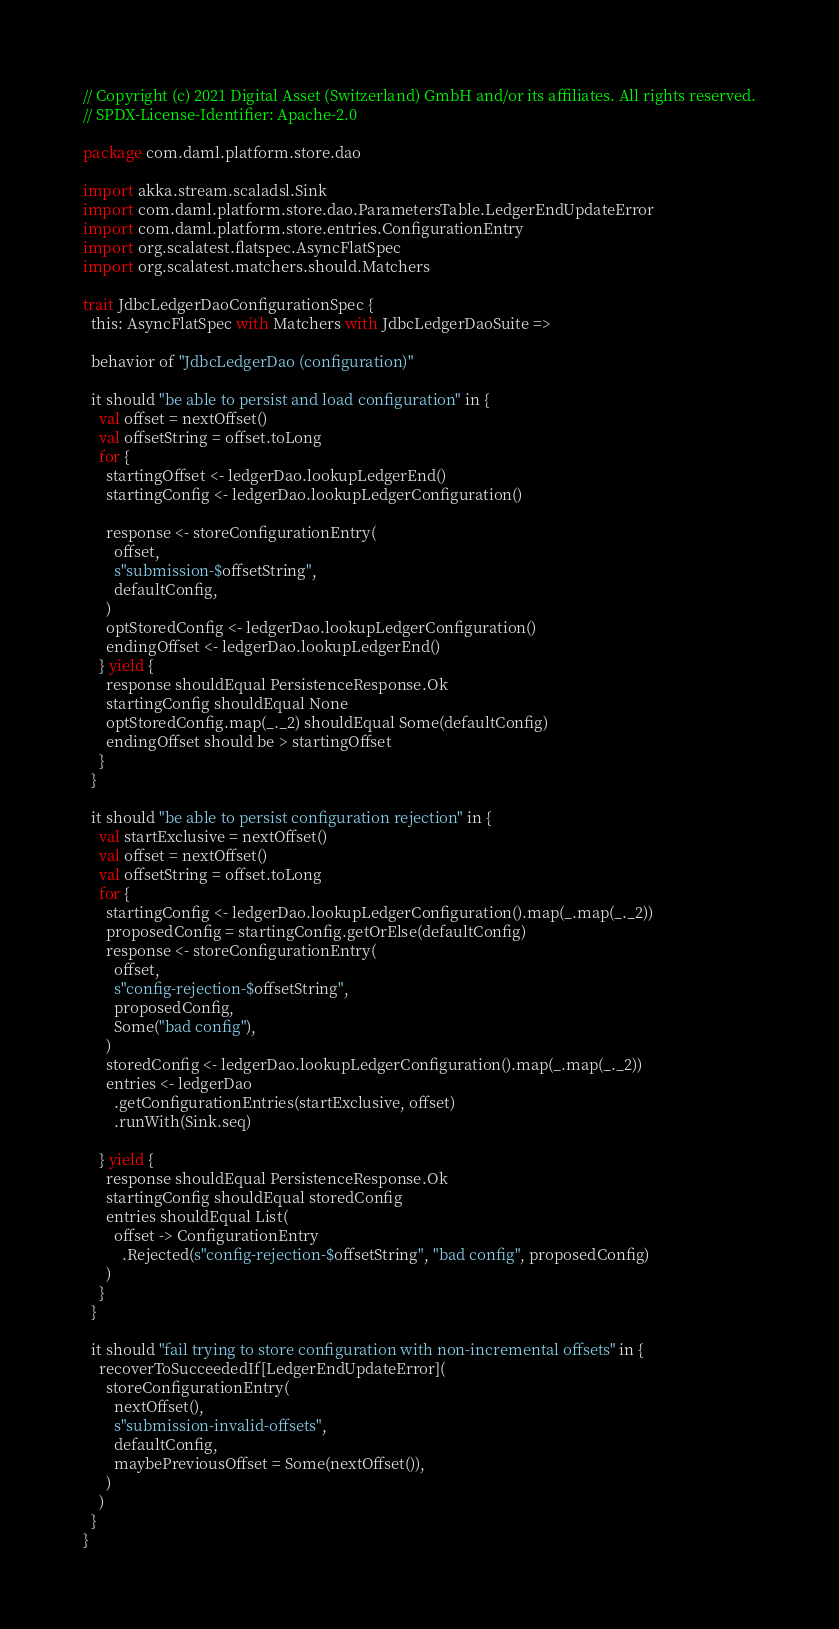<code> <loc_0><loc_0><loc_500><loc_500><_Scala_>// Copyright (c) 2021 Digital Asset (Switzerland) GmbH and/or its affiliates. All rights reserved.
// SPDX-License-Identifier: Apache-2.0

package com.daml.platform.store.dao

import akka.stream.scaladsl.Sink
import com.daml.platform.store.dao.ParametersTable.LedgerEndUpdateError
import com.daml.platform.store.entries.ConfigurationEntry
import org.scalatest.flatspec.AsyncFlatSpec
import org.scalatest.matchers.should.Matchers

trait JdbcLedgerDaoConfigurationSpec {
  this: AsyncFlatSpec with Matchers with JdbcLedgerDaoSuite =>

  behavior of "JdbcLedgerDao (configuration)"

  it should "be able to persist and load configuration" in {
    val offset = nextOffset()
    val offsetString = offset.toLong
    for {
      startingOffset <- ledgerDao.lookupLedgerEnd()
      startingConfig <- ledgerDao.lookupLedgerConfiguration()

      response <- storeConfigurationEntry(
        offset,
        s"submission-$offsetString",
        defaultConfig,
      )
      optStoredConfig <- ledgerDao.lookupLedgerConfiguration()
      endingOffset <- ledgerDao.lookupLedgerEnd()
    } yield {
      response shouldEqual PersistenceResponse.Ok
      startingConfig shouldEqual None
      optStoredConfig.map(_._2) shouldEqual Some(defaultConfig)
      endingOffset should be > startingOffset
    }
  }

  it should "be able to persist configuration rejection" in {
    val startExclusive = nextOffset()
    val offset = nextOffset()
    val offsetString = offset.toLong
    for {
      startingConfig <- ledgerDao.lookupLedgerConfiguration().map(_.map(_._2))
      proposedConfig = startingConfig.getOrElse(defaultConfig)
      response <- storeConfigurationEntry(
        offset,
        s"config-rejection-$offsetString",
        proposedConfig,
        Some("bad config"),
      )
      storedConfig <- ledgerDao.lookupLedgerConfiguration().map(_.map(_._2))
      entries <- ledgerDao
        .getConfigurationEntries(startExclusive, offset)
        .runWith(Sink.seq)

    } yield {
      response shouldEqual PersistenceResponse.Ok
      startingConfig shouldEqual storedConfig
      entries shouldEqual List(
        offset -> ConfigurationEntry
          .Rejected(s"config-rejection-$offsetString", "bad config", proposedConfig)
      )
    }
  }

  it should "fail trying to store configuration with non-incremental offsets" in {
    recoverToSucceededIf[LedgerEndUpdateError](
      storeConfigurationEntry(
        nextOffset(),
        s"submission-invalid-offsets",
        defaultConfig,
        maybePreviousOffset = Some(nextOffset()),
      )
    )
  }
}
</code> 